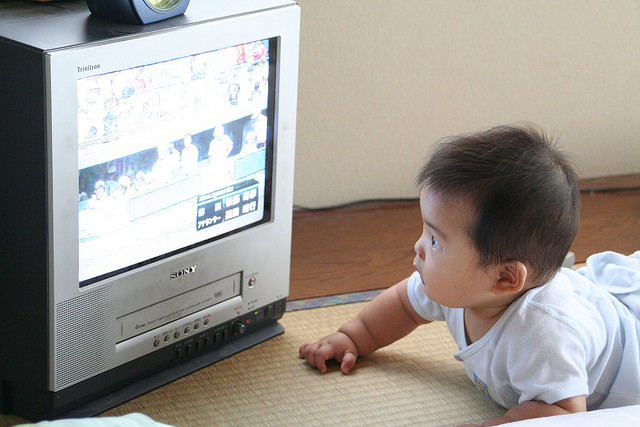<image>What game console is that? There is no game console in the image. However, it might be a Wii. What game console is that? I don't know what game console is shown in the image. It can be Wii or any other console. 